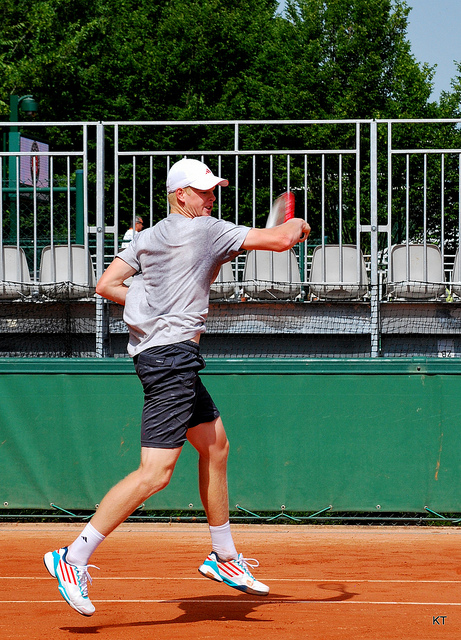<image>What sport is being played? The sport being played is unknown. It can be tennis. What sport is being played? The sport being played is tennis. 